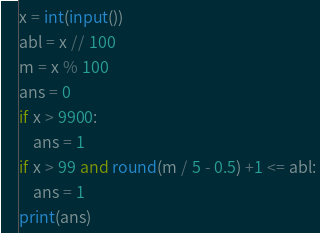Convert code to text. <code><loc_0><loc_0><loc_500><loc_500><_Python_>x = int(input())
abl = x // 100
m = x % 100
ans = 0
if x > 9900:
    ans = 1
if x > 99 and round(m / 5 - 0.5) +1 <= abl:
    ans = 1
print(ans)</code> 